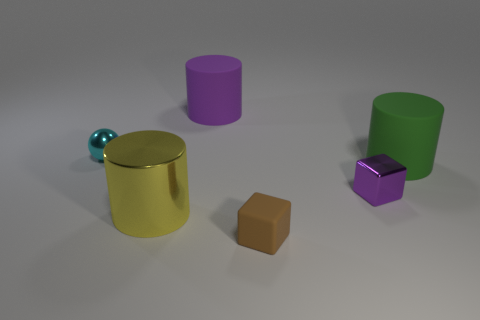There is a large purple object that is the same shape as the yellow thing; what is its material?
Provide a succinct answer. Rubber. The tiny brown object that is made of the same material as the big green thing is what shape?
Make the answer very short. Cube. Do the brown object and the green cylinder have the same material?
Your answer should be compact. Yes. Is there any other thing that is the same material as the brown thing?
Your answer should be very brief. Yes. Is the number of small matte blocks to the right of the big green rubber cylinder greater than the number of large gray metallic things?
Provide a short and direct response. No. Is the shiny cube the same color as the metallic cylinder?
Your answer should be compact. No. What number of green rubber things are the same shape as the purple metal thing?
Keep it short and to the point. 0. There is a purple block that is the same material as the yellow cylinder; what is its size?
Your answer should be very brief. Small. There is a cylinder that is behind the small purple shiny cube and left of the green object; what color is it?
Offer a terse response. Purple. How many rubber cubes are the same size as the shiny cylinder?
Make the answer very short. 0. 